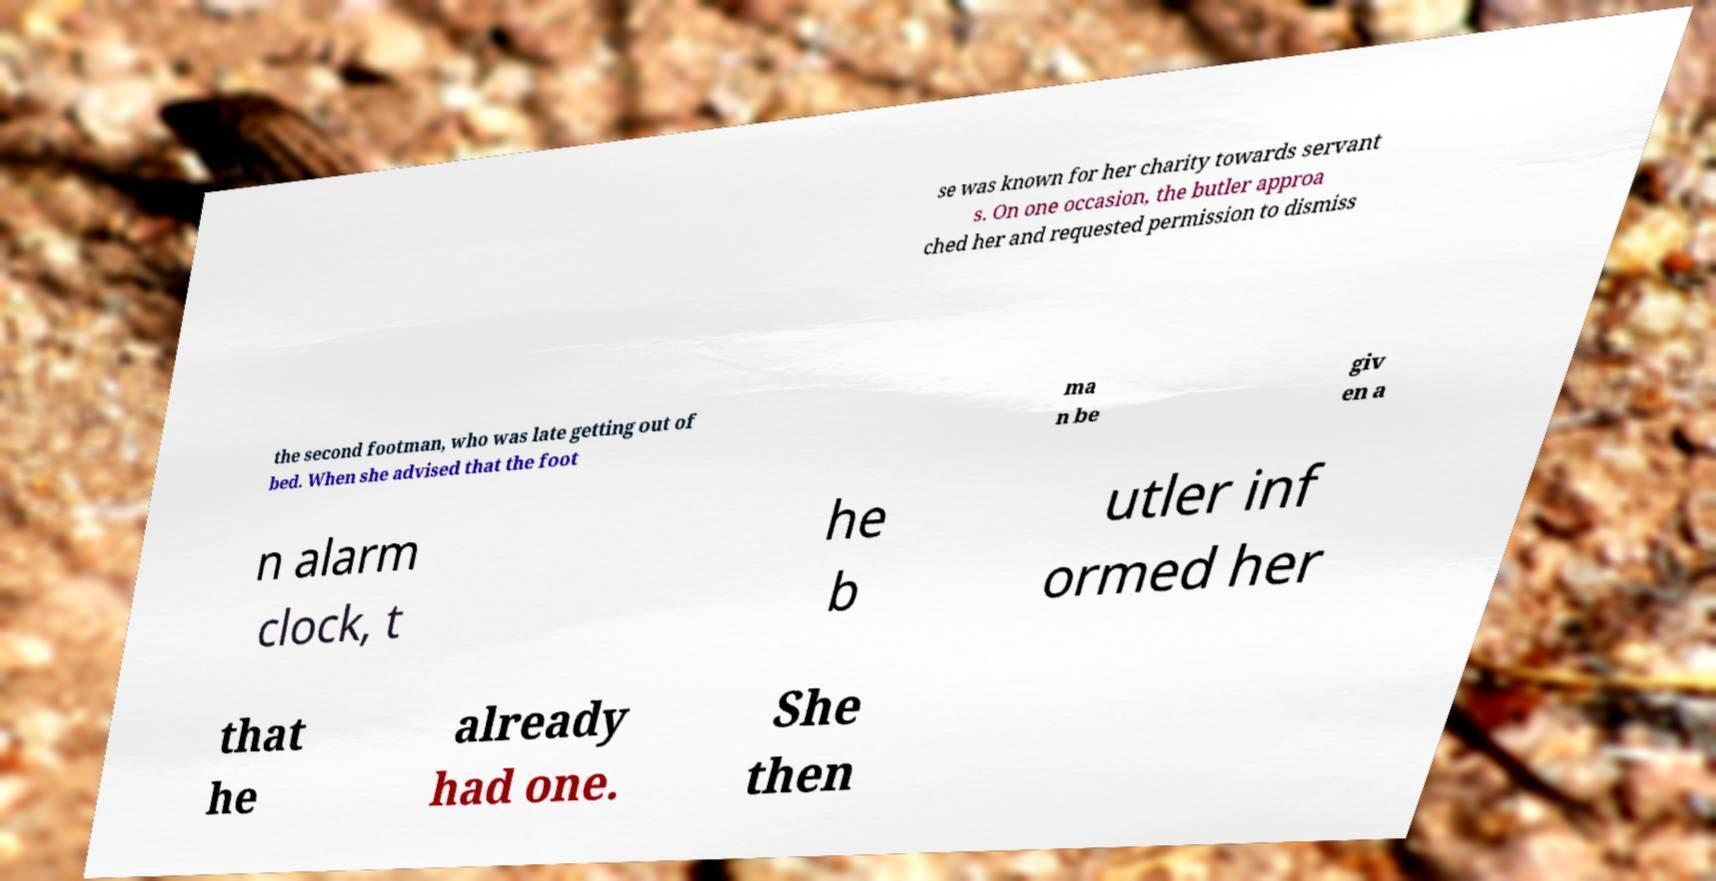I need the written content from this picture converted into text. Can you do that? se was known for her charity towards servant s. On one occasion, the butler approa ched her and requested permission to dismiss the second footman, who was late getting out of bed. When she advised that the foot ma n be giv en a n alarm clock, t he b utler inf ormed her that he already had one. She then 